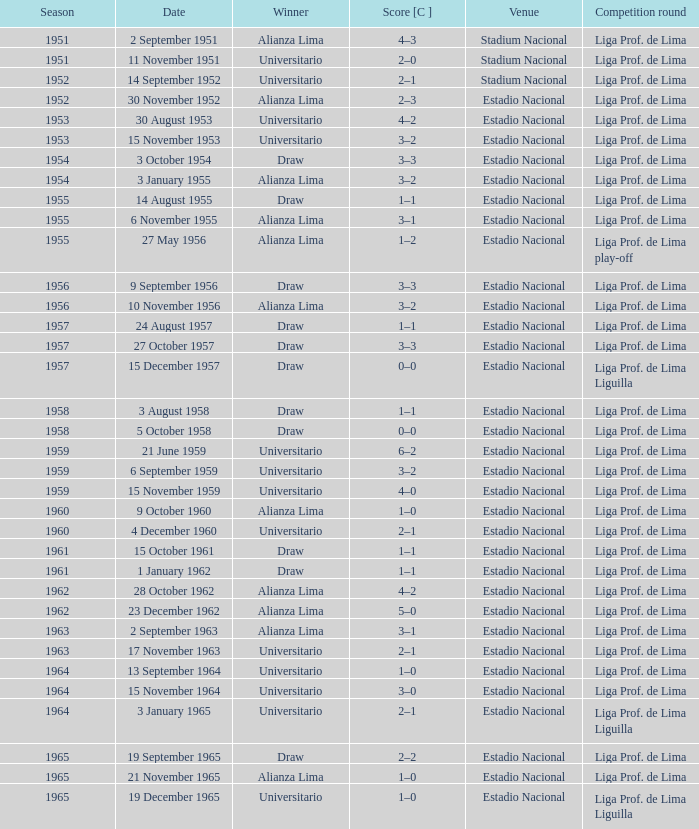What is the most recent season with a date of 27 October 1957? 1957.0. 